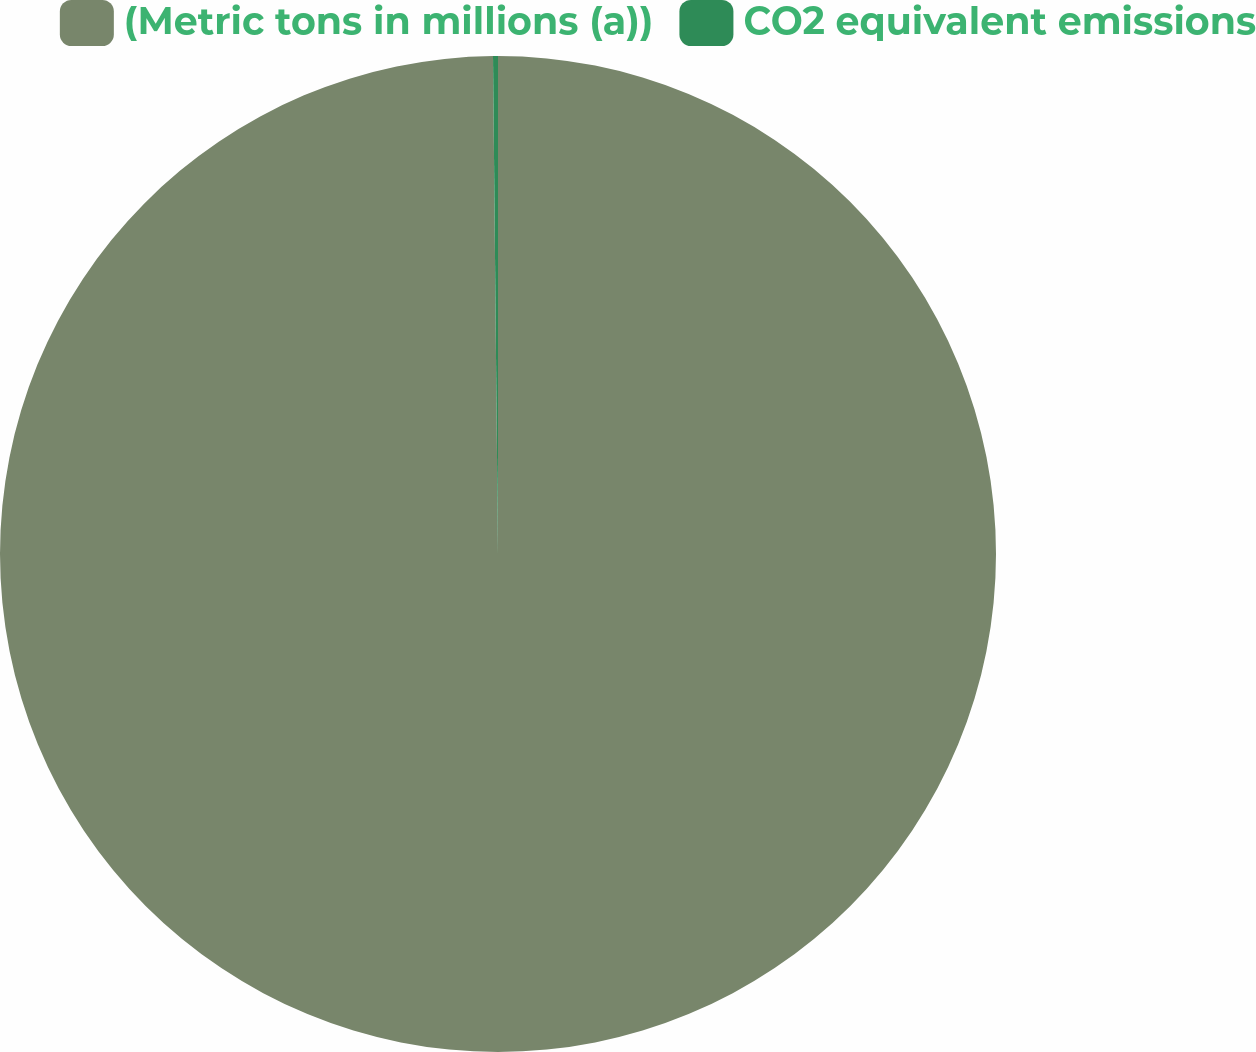Convert chart to OTSL. <chart><loc_0><loc_0><loc_500><loc_500><pie_chart><fcel>(Metric tons in millions (a))<fcel>CO2 equivalent emissions<nl><fcel>99.84%<fcel>0.16%<nl></chart> 